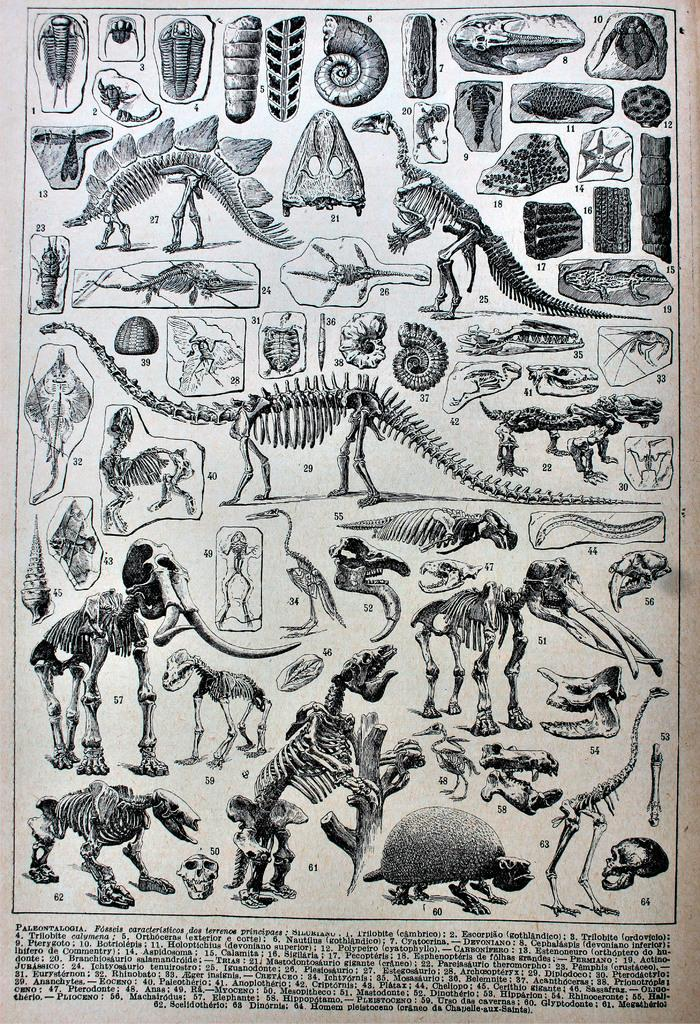What is depicted on the poster in the image? The poster contains animal skeletons. How are the animal skeletons organized on the poster? The animal skeletons are labeled with numbers. Is there any text accompanying the poster in the image? Yes, there is text at the bottom of the image. Can you tell me how many bubbles are floating around the robin in the image? There is no robin or bubbles present in the image; it features a poster with animal skeletons. 